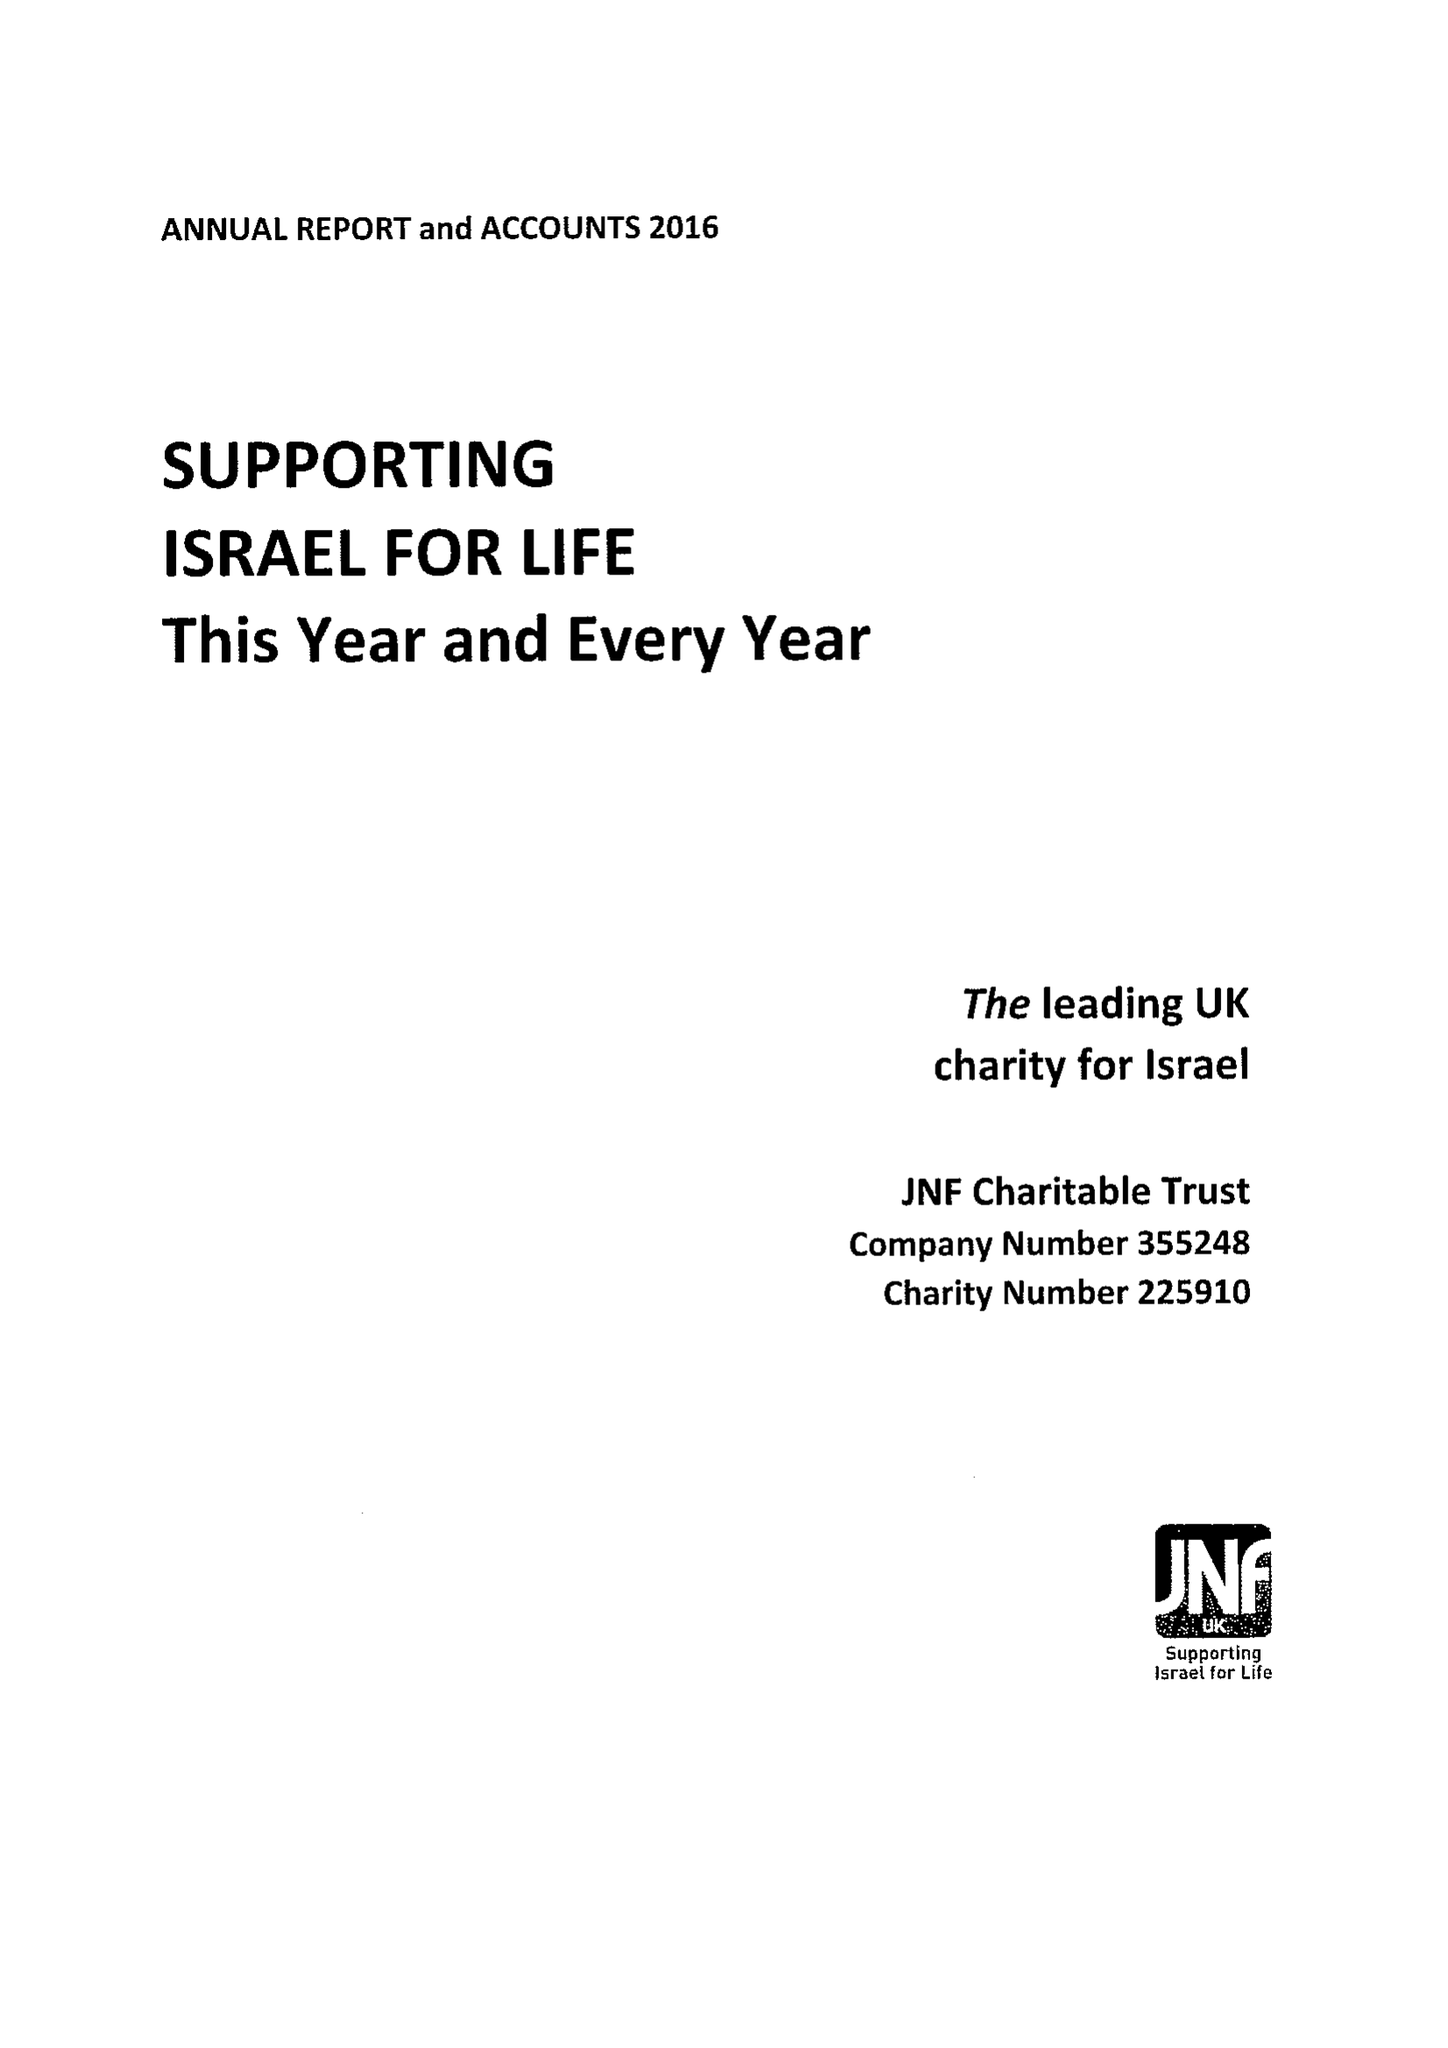What is the value for the spending_annually_in_british_pounds?
Answer the question using a single word or phrase. 11178000.00 